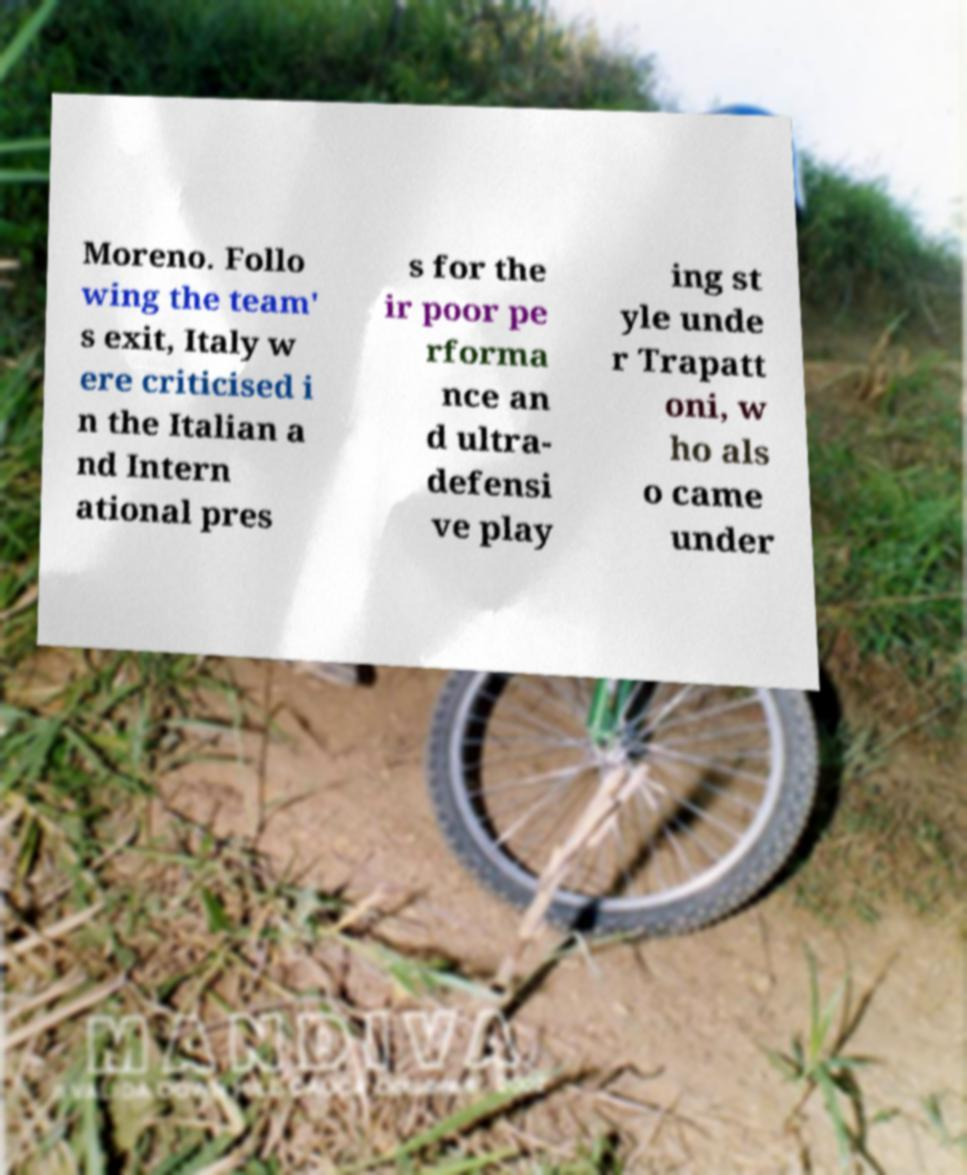There's text embedded in this image that I need extracted. Can you transcribe it verbatim? Moreno. Follo wing the team' s exit, Italy w ere criticised i n the Italian a nd Intern ational pres s for the ir poor pe rforma nce an d ultra- defensi ve play ing st yle unde r Trapatt oni, w ho als o came under 